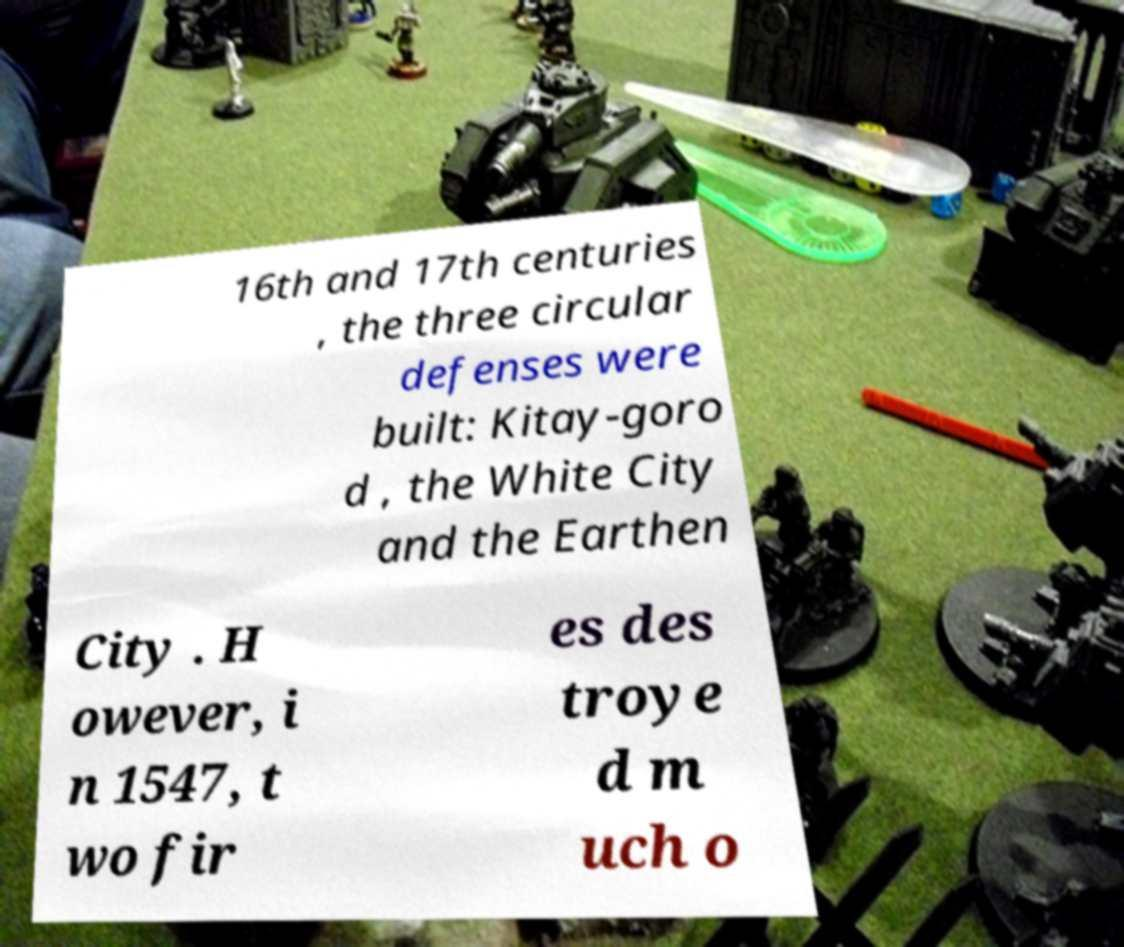There's text embedded in this image that I need extracted. Can you transcribe it verbatim? 16th and 17th centuries , the three circular defenses were built: Kitay-goro d , the White City and the Earthen City . H owever, i n 1547, t wo fir es des troye d m uch o 